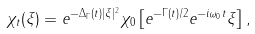Convert formula to latex. <formula><loc_0><loc_0><loc_500><loc_500>\chi _ { t } ( \xi ) = e ^ { - \Delta _ { \Gamma } ( t ) | \xi | ^ { 2 } } \chi _ { 0 } \left [ e ^ { - \Gamma ( t ) / 2 } e ^ { - i \omega _ { 0 } t } \xi \right ] ,</formula> 